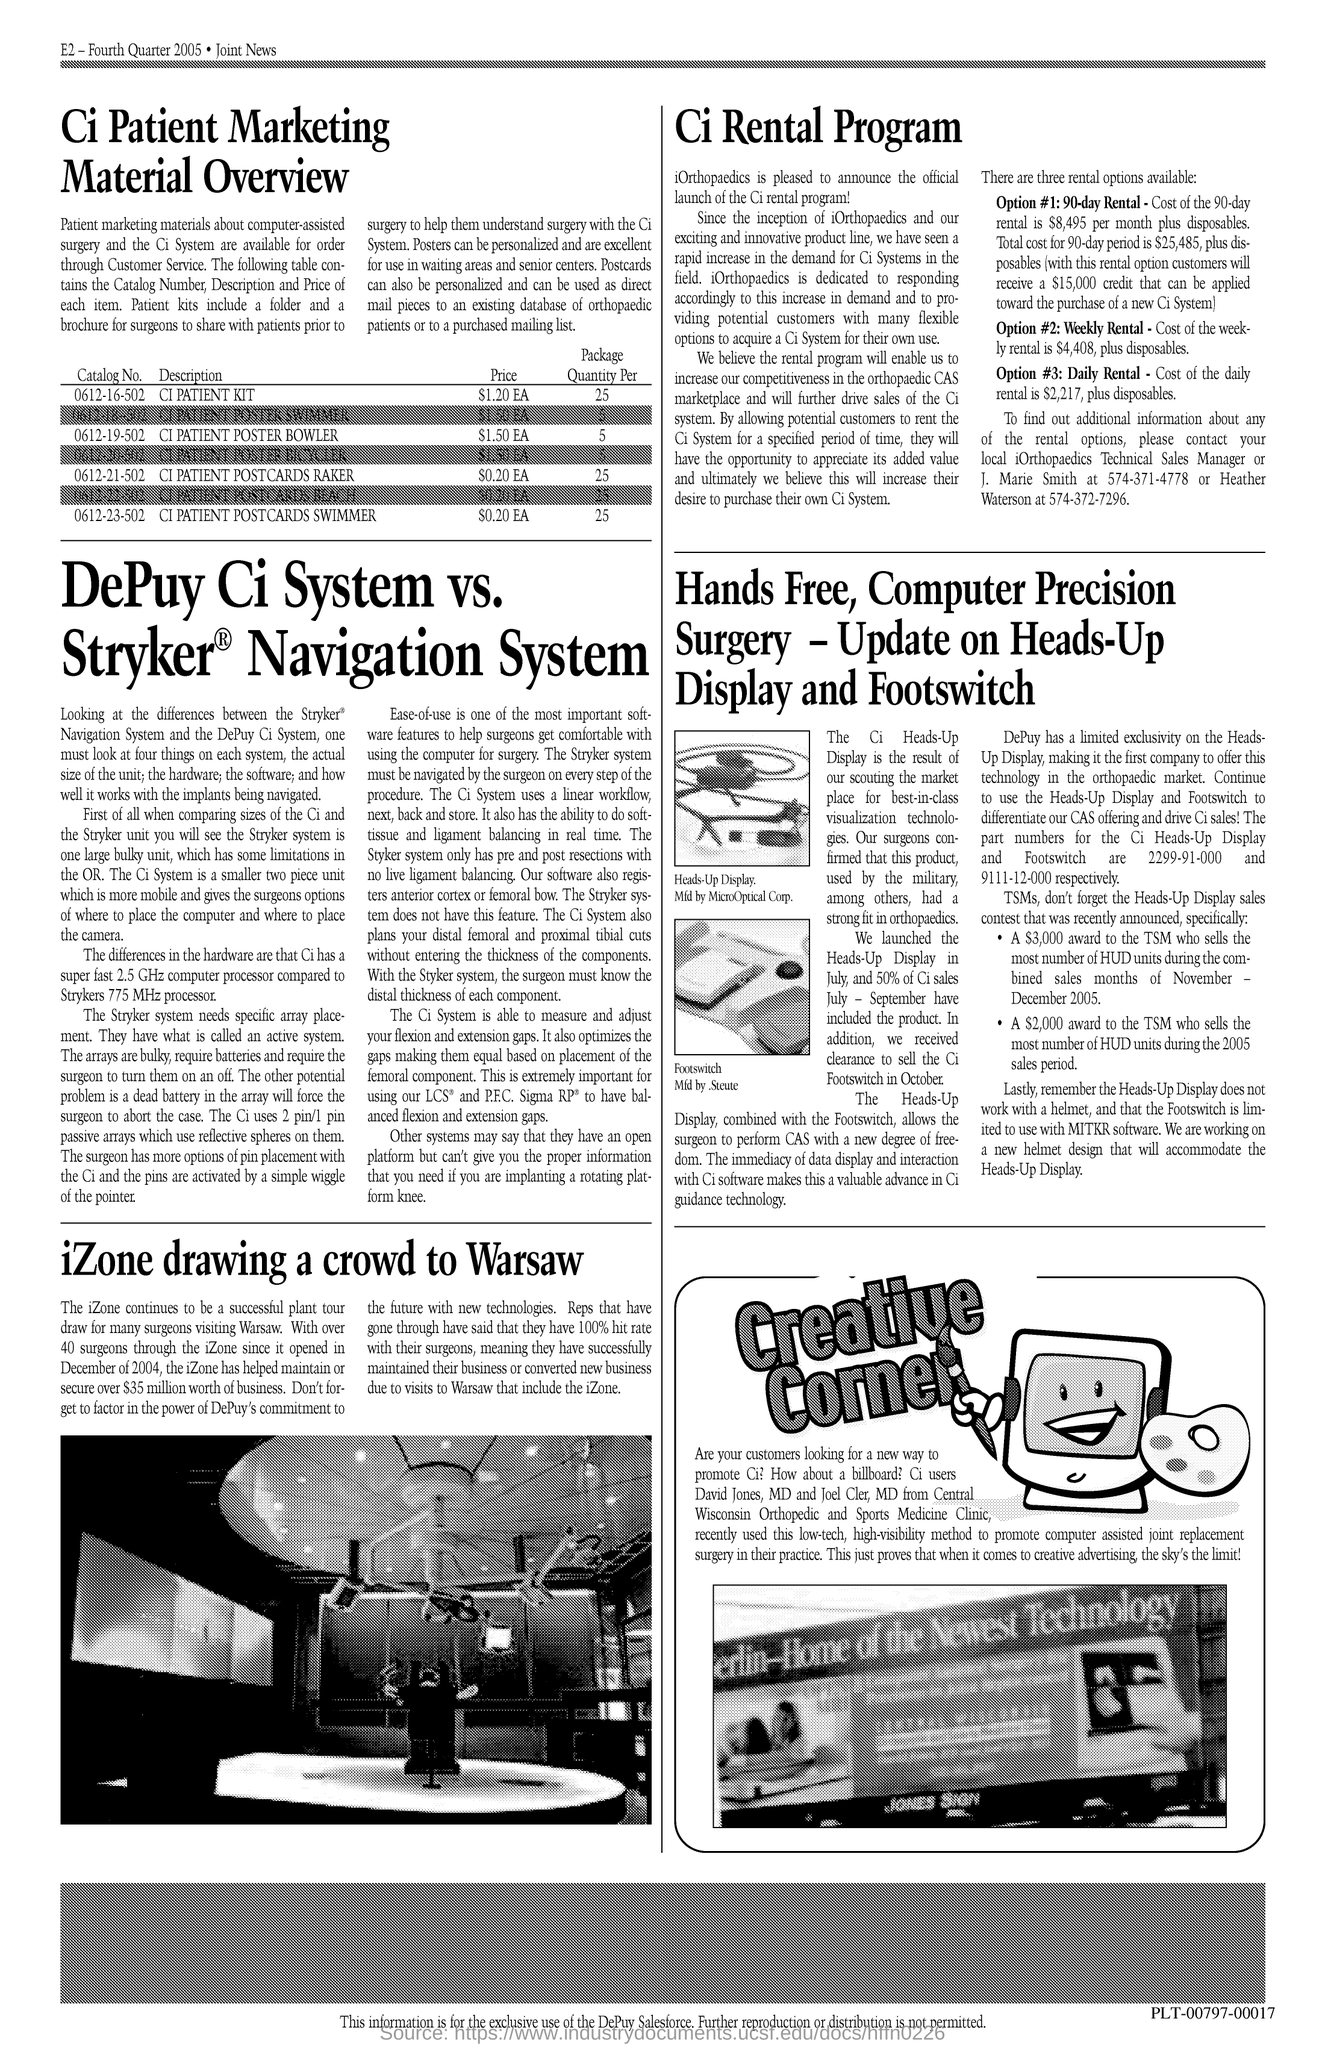What is option number 1?
Give a very brief answer. 90-day Rental. What is option number 2?
Your answer should be compact. Weekly Rental. What is option number 3?
Give a very brief answer. Daily Rental. 